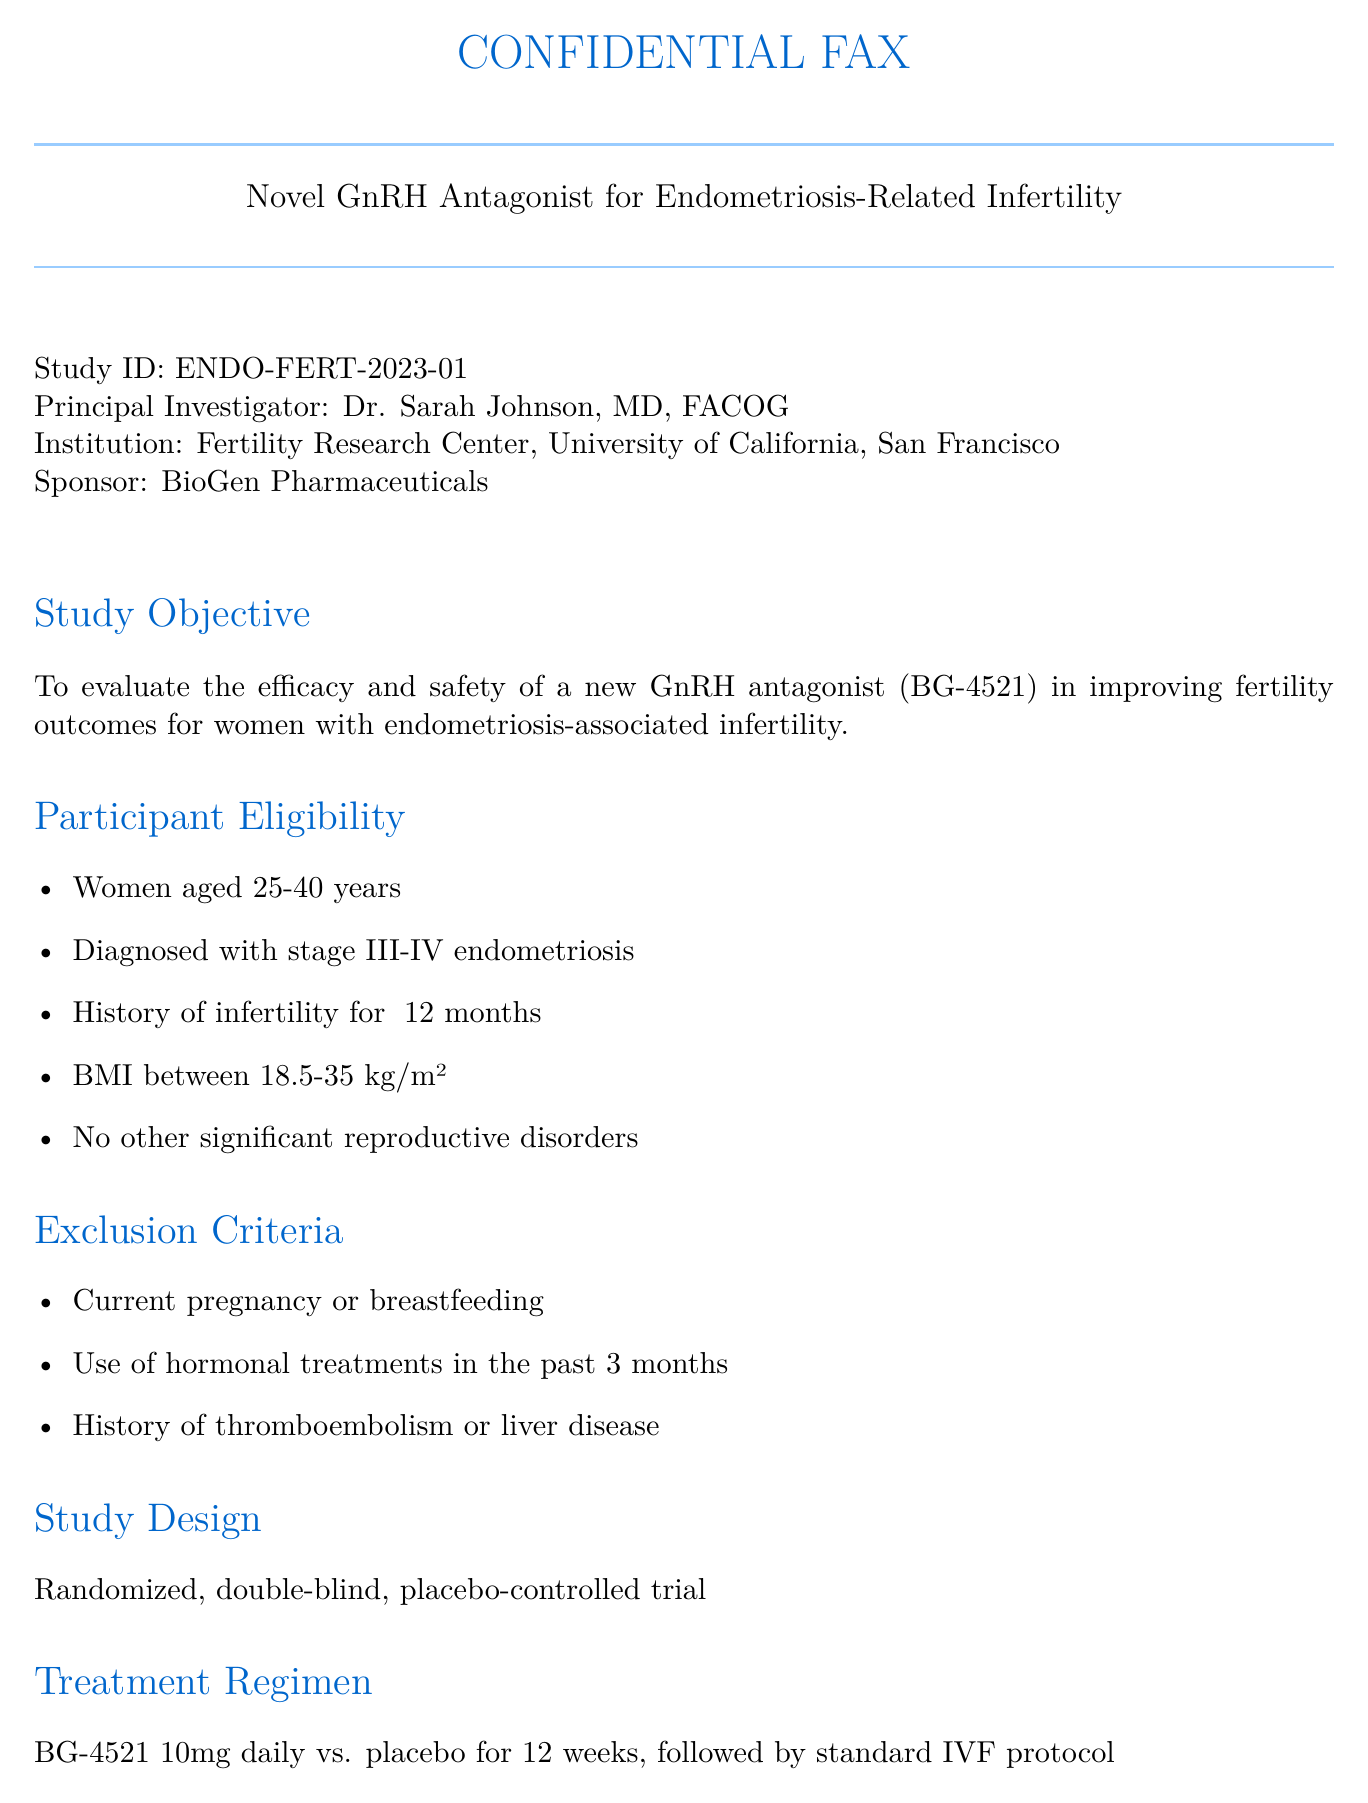What is the study ID? The study ID is a specific identifier for the research protocol, which in this case is ENDO-FERT-2023-01.
Answer: ENDO-FERT-2023-01 Who is the principal investigator? The principal investigator is the individual leading the study, noted as Dr. Sarah Johnson, MD, FACOG.
Answer: Dr. Sarah Johnson, MD, FACOG What is the age range for participant eligibility? The age range specifies the acceptable ages of participants, which is indicated as 25-40 years.
Answer: 25-40 years What is the duration of the treatment phase? The duration of the treatment phase indicates how long the treatment will be administered, which is 6 months or 26 weeks (January 2024 - June 2024).
Answer: 12 weeks What is the primary objective of the study? The primary objective outlines the main purpose of the research, which is to evaluate the efficacy and safety of BG-4521 in improving fertility outcomes.
Answer: To evaluate the efficacy and safety of a new GnRH antagonist (BG-4521) What are the exclusion criteria for participants? The exclusion criteria includes specific conditions or situations where individuals would not qualify, such as current pregnancy or history of thromboembolism.
Answer: Current pregnancy or breastfeeding When does recruitment for the study start? Recruitment indicates the beginning of participant enrollment for the study, which starts in June 2023.
Answer: June 2023 What type of trial design is being used? The trial design explains the methodological framework of the study, which is randomized, double-blind, placebo-controlled.
Answer: Randomized, double-blind, placebo-controlled trial 